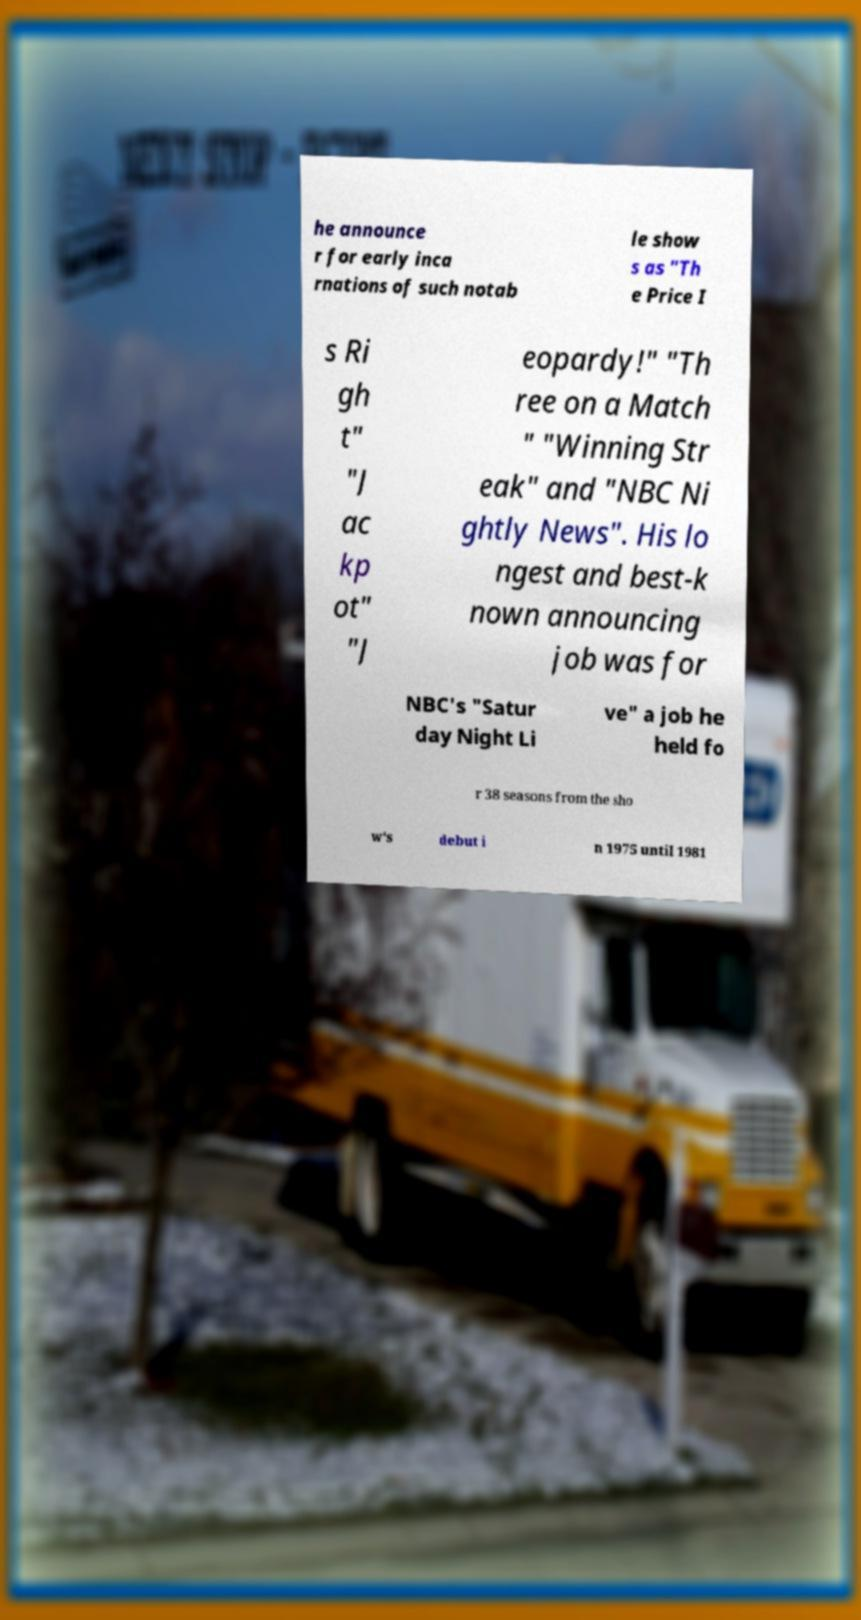Can you read and provide the text displayed in the image?This photo seems to have some interesting text. Can you extract and type it out for me? he announce r for early inca rnations of such notab le show s as "Th e Price I s Ri gh t" "J ac kp ot" "J eopardy!" "Th ree on a Match " "Winning Str eak" and "NBC Ni ghtly News". His lo ngest and best-k nown announcing job was for NBC's "Satur day Night Li ve" a job he held fo r 38 seasons from the sho w's debut i n 1975 until 1981 